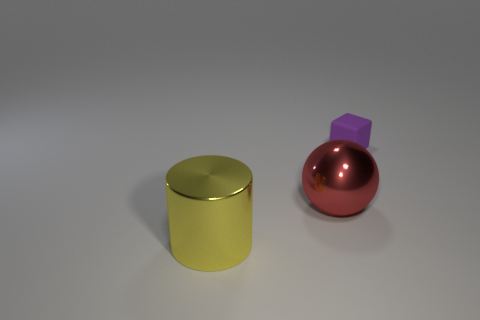Are there any other things that have the same size as the cube?
Your answer should be very brief. No. Is there another object made of the same material as the large yellow object?
Give a very brief answer. Yes. The yellow shiny thing has what shape?
Offer a terse response. Cylinder. What number of small purple blocks are there?
Your answer should be compact. 1. The big thing that is to the left of the shiny thing on the right side of the yellow cylinder is what color?
Your response must be concise. Yellow. What is the color of the thing that is the same size as the metallic cylinder?
Your answer should be very brief. Red. Are any small cyan shiny balls visible?
Give a very brief answer. No. What is the shape of the metallic thing that is behind the cylinder?
Your answer should be compact. Sphere. What number of objects are both right of the large cylinder and on the left side of the tiny block?
Provide a short and direct response. 1. How many other things are the same size as the purple block?
Offer a very short reply. 0. 